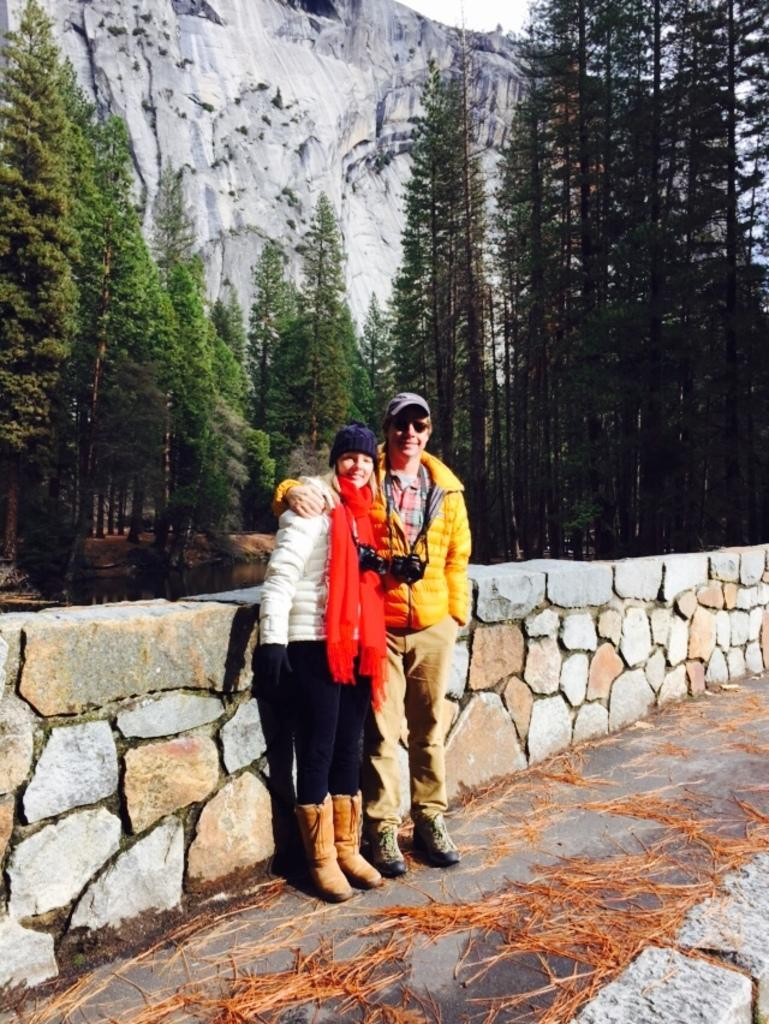How many people are standing on the platform in the image? There are two persons standing on a platform in the image. What can be seen behind the platform? There is a wall in the image. What type of vegetation is present in the image? Dried grass is present in the image. What other natural elements can be seen in the image? There are trees and a mountain in the image. What is visible above the platform and the wall? The sky is visible in the image. What type of flower is being taught by the secretary in the image? There is no secretary or flower present in the image. 